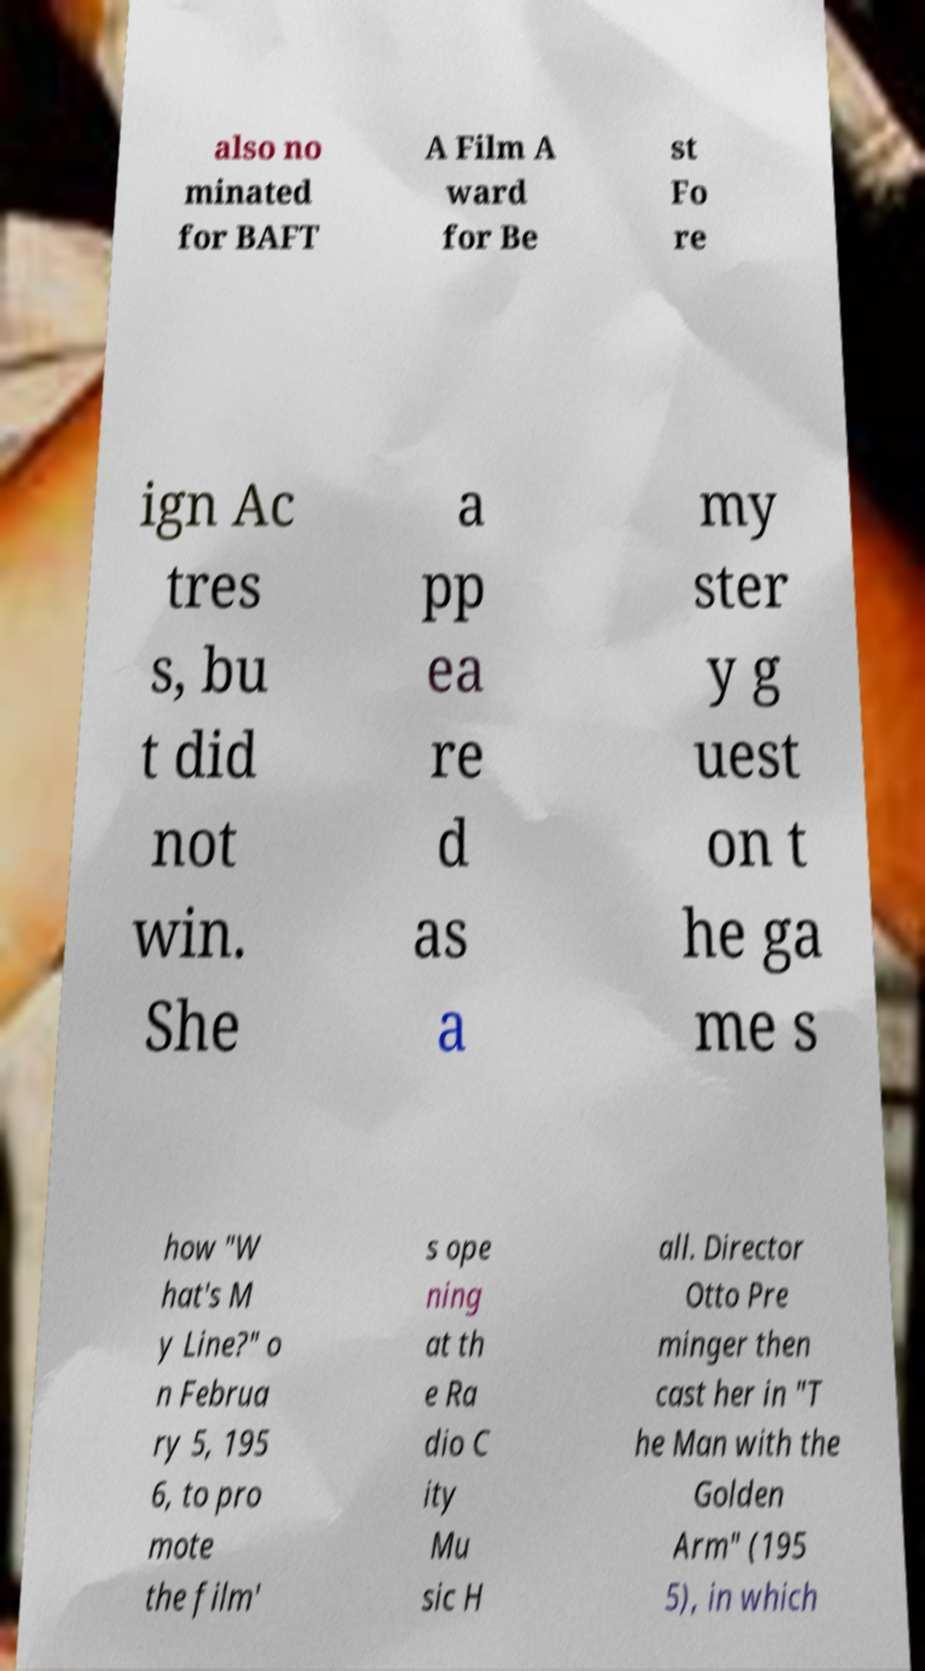Could you assist in decoding the text presented in this image and type it out clearly? also no minated for BAFT A Film A ward for Be st Fo re ign Ac tres s, bu t did not win. She a pp ea re d as a my ster y g uest on t he ga me s how "W hat's M y Line?" o n Februa ry 5, 195 6, to pro mote the film' s ope ning at th e Ra dio C ity Mu sic H all. Director Otto Pre minger then cast her in "T he Man with the Golden Arm" (195 5), in which 